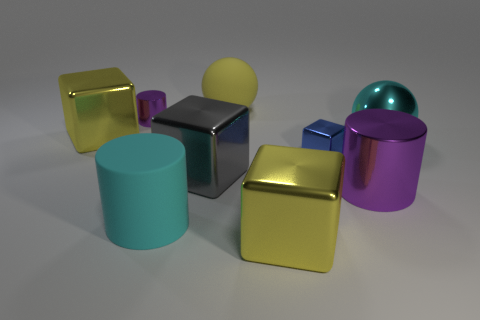What is the shape of the large yellow thing behind the purple cylinder behind the blue thing?
Offer a terse response. Sphere. Are any blue objects visible?
Your answer should be very brief. Yes. There is a cylinder left of the cyan matte object; what is its color?
Provide a short and direct response. Purple. What is the material of the other cylinder that is the same color as the big shiny cylinder?
Ensure brevity in your answer.  Metal. There is a cyan matte cylinder; are there any big cyan cylinders left of it?
Your answer should be compact. No. Are there more small cyan shiny cubes than big cyan balls?
Ensure brevity in your answer.  No. There is a tiny object that is right of the cube that is in front of the big cyan thing that is left of the blue metallic block; what color is it?
Offer a very short reply. Blue. There is a sphere that is the same material as the big cyan cylinder; what is its color?
Make the answer very short. Yellow. Are there any other things that have the same size as the cyan metallic sphere?
Your answer should be very brief. Yes. How many objects are either large yellow metallic cubes that are to the right of the large gray object or cylinders in front of the tiny blue object?
Give a very brief answer. 3. 